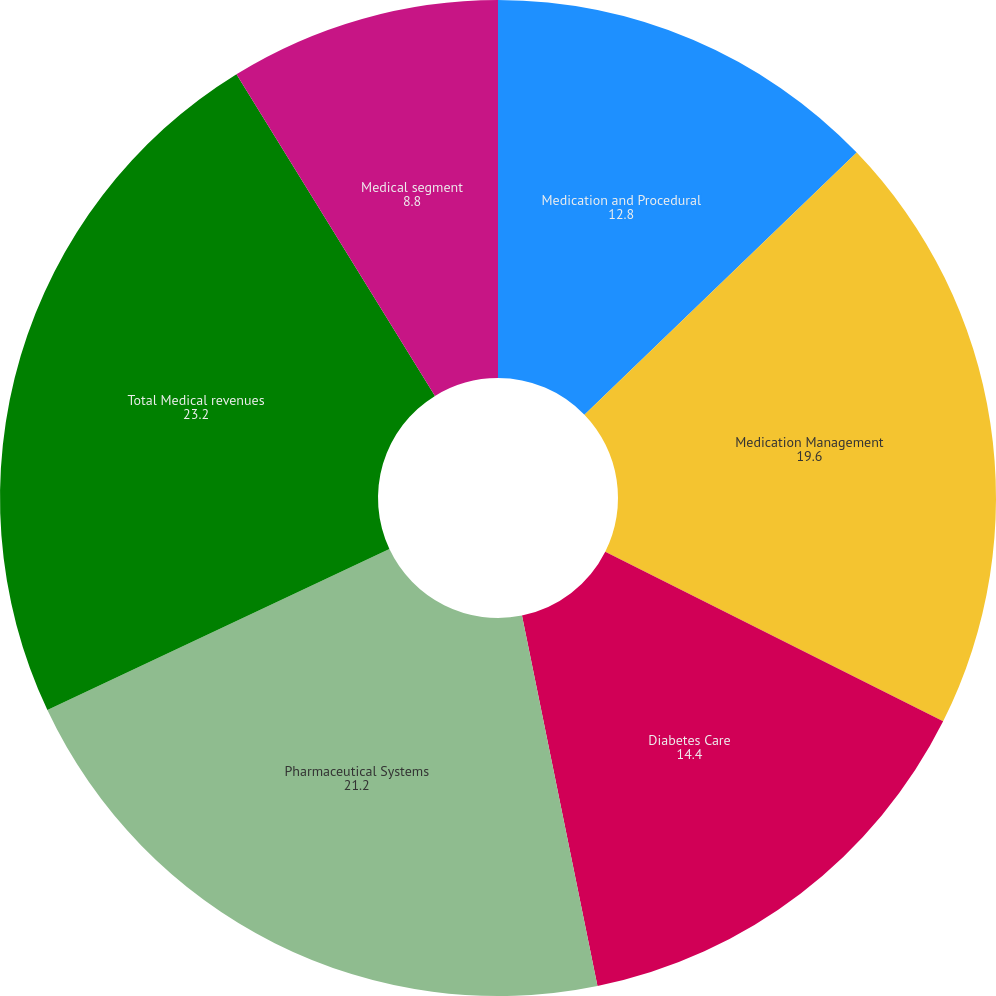Convert chart to OTSL. <chart><loc_0><loc_0><loc_500><loc_500><pie_chart><fcel>Medication and Procedural<fcel>Medication Management<fcel>Diabetes Care<fcel>Pharmaceutical Systems<fcel>Total Medical revenues<fcel>Medical segment<nl><fcel>12.8%<fcel>19.6%<fcel>14.4%<fcel>21.2%<fcel>23.2%<fcel>8.8%<nl></chart> 